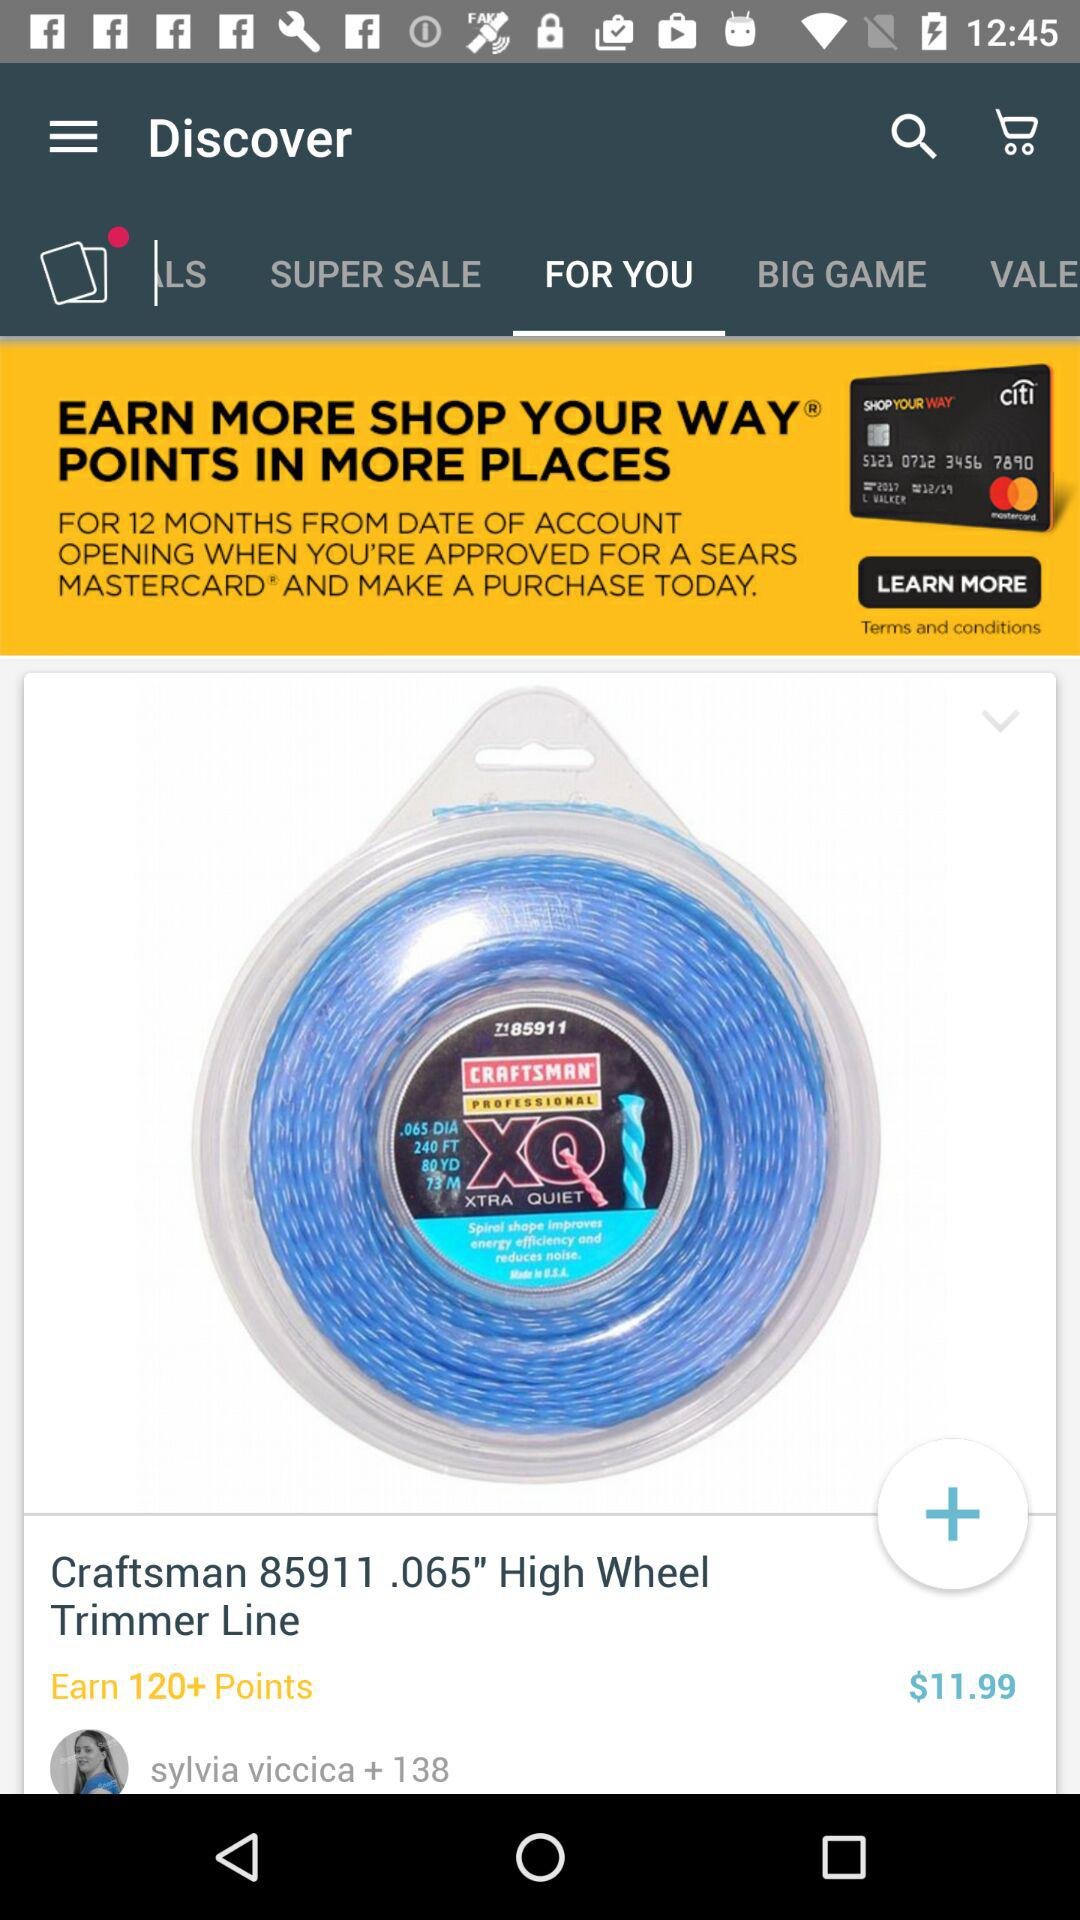How many points do I earn for buying this product? For buying this product, you will earn 120+ points. 